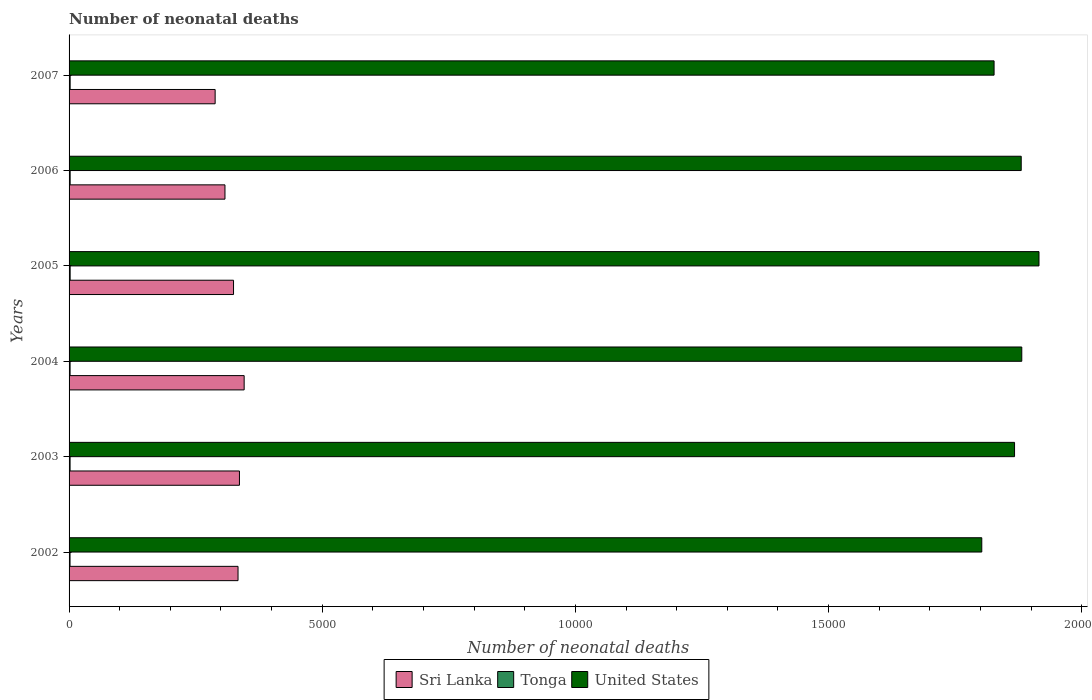How many bars are there on the 4th tick from the bottom?
Provide a succinct answer. 3. In how many cases, is the number of bars for a given year not equal to the number of legend labels?
Your response must be concise. 0. What is the number of neonatal deaths in in Sri Lanka in 2004?
Your answer should be very brief. 3458. Across all years, what is the maximum number of neonatal deaths in in United States?
Give a very brief answer. 1.92e+04. Across all years, what is the minimum number of neonatal deaths in in Tonga?
Provide a short and direct response. 19. In which year was the number of neonatal deaths in in United States maximum?
Your answer should be compact. 2005. What is the total number of neonatal deaths in in Tonga in the graph?
Provide a short and direct response. 122. What is the difference between the number of neonatal deaths in in Tonga in 2002 and that in 2005?
Provide a succinct answer. -2. What is the difference between the number of neonatal deaths in in United States in 2003 and the number of neonatal deaths in in Sri Lanka in 2002?
Provide a succinct answer. 1.53e+04. What is the average number of neonatal deaths in in United States per year?
Provide a succinct answer. 1.86e+04. In the year 2004, what is the difference between the number of neonatal deaths in in United States and number of neonatal deaths in in Tonga?
Offer a very short reply. 1.88e+04. In how many years, is the number of neonatal deaths in in Tonga greater than 1000 ?
Your response must be concise. 0. What is the ratio of the number of neonatal deaths in in United States in 2004 to that in 2007?
Ensure brevity in your answer.  1.03. Is the number of neonatal deaths in in United States in 2004 less than that in 2006?
Offer a very short reply. No. Is the difference between the number of neonatal deaths in in United States in 2002 and 2003 greater than the difference between the number of neonatal deaths in in Tonga in 2002 and 2003?
Offer a terse response. No. What is the difference between the highest and the second highest number of neonatal deaths in in Tonga?
Provide a succinct answer. 0. What is the difference between the highest and the lowest number of neonatal deaths in in Tonga?
Provide a succinct answer. 2. In how many years, is the number of neonatal deaths in in Sri Lanka greater than the average number of neonatal deaths in in Sri Lanka taken over all years?
Offer a terse response. 4. Is the sum of the number of neonatal deaths in in Tonga in 2005 and 2006 greater than the maximum number of neonatal deaths in in Sri Lanka across all years?
Your answer should be compact. No. What does the 2nd bar from the top in 2005 represents?
Ensure brevity in your answer.  Tonga. What does the 1st bar from the bottom in 2005 represents?
Offer a very short reply. Sri Lanka. How many years are there in the graph?
Your response must be concise. 6. How are the legend labels stacked?
Give a very brief answer. Horizontal. What is the title of the graph?
Offer a terse response. Number of neonatal deaths. What is the label or title of the X-axis?
Offer a very short reply. Number of neonatal deaths. What is the label or title of the Y-axis?
Make the answer very short. Years. What is the Number of neonatal deaths in Sri Lanka in 2002?
Offer a terse response. 3337. What is the Number of neonatal deaths in United States in 2002?
Give a very brief answer. 1.80e+04. What is the Number of neonatal deaths of Sri Lanka in 2003?
Ensure brevity in your answer.  3365. What is the Number of neonatal deaths of United States in 2003?
Make the answer very short. 1.87e+04. What is the Number of neonatal deaths of Sri Lanka in 2004?
Ensure brevity in your answer.  3458. What is the Number of neonatal deaths in Tonga in 2004?
Provide a short and direct response. 20. What is the Number of neonatal deaths in United States in 2004?
Ensure brevity in your answer.  1.88e+04. What is the Number of neonatal deaths of Sri Lanka in 2005?
Your response must be concise. 3248. What is the Number of neonatal deaths of United States in 2005?
Keep it short and to the point. 1.92e+04. What is the Number of neonatal deaths of Sri Lanka in 2006?
Make the answer very short. 3079. What is the Number of neonatal deaths in United States in 2006?
Keep it short and to the point. 1.88e+04. What is the Number of neonatal deaths of Sri Lanka in 2007?
Make the answer very short. 2885. What is the Number of neonatal deaths in United States in 2007?
Offer a terse response. 1.83e+04. Across all years, what is the maximum Number of neonatal deaths of Sri Lanka?
Offer a very short reply. 3458. Across all years, what is the maximum Number of neonatal deaths of United States?
Keep it short and to the point. 1.92e+04. Across all years, what is the minimum Number of neonatal deaths in Sri Lanka?
Provide a succinct answer. 2885. Across all years, what is the minimum Number of neonatal deaths of United States?
Provide a short and direct response. 1.80e+04. What is the total Number of neonatal deaths of Sri Lanka in the graph?
Provide a short and direct response. 1.94e+04. What is the total Number of neonatal deaths in Tonga in the graph?
Provide a succinct answer. 122. What is the total Number of neonatal deaths in United States in the graph?
Your answer should be compact. 1.12e+05. What is the difference between the Number of neonatal deaths of Sri Lanka in 2002 and that in 2003?
Ensure brevity in your answer.  -28. What is the difference between the Number of neonatal deaths of United States in 2002 and that in 2003?
Make the answer very short. -647. What is the difference between the Number of neonatal deaths in Sri Lanka in 2002 and that in 2004?
Ensure brevity in your answer.  -121. What is the difference between the Number of neonatal deaths in Tonga in 2002 and that in 2004?
Your answer should be compact. -1. What is the difference between the Number of neonatal deaths of United States in 2002 and that in 2004?
Offer a terse response. -790. What is the difference between the Number of neonatal deaths of Sri Lanka in 2002 and that in 2005?
Keep it short and to the point. 89. What is the difference between the Number of neonatal deaths of United States in 2002 and that in 2005?
Provide a succinct answer. -1130. What is the difference between the Number of neonatal deaths in Sri Lanka in 2002 and that in 2006?
Provide a short and direct response. 258. What is the difference between the Number of neonatal deaths of United States in 2002 and that in 2006?
Make the answer very short. -779. What is the difference between the Number of neonatal deaths in Sri Lanka in 2002 and that in 2007?
Provide a succinct answer. 452. What is the difference between the Number of neonatal deaths of Tonga in 2002 and that in 2007?
Offer a very short reply. -2. What is the difference between the Number of neonatal deaths of United States in 2002 and that in 2007?
Make the answer very short. -243. What is the difference between the Number of neonatal deaths of Sri Lanka in 2003 and that in 2004?
Keep it short and to the point. -93. What is the difference between the Number of neonatal deaths of Tonga in 2003 and that in 2004?
Make the answer very short. 0. What is the difference between the Number of neonatal deaths of United States in 2003 and that in 2004?
Keep it short and to the point. -143. What is the difference between the Number of neonatal deaths in Sri Lanka in 2003 and that in 2005?
Offer a very short reply. 117. What is the difference between the Number of neonatal deaths in United States in 2003 and that in 2005?
Provide a succinct answer. -483. What is the difference between the Number of neonatal deaths of Sri Lanka in 2003 and that in 2006?
Provide a short and direct response. 286. What is the difference between the Number of neonatal deaths in United States in 2003 and that in 2006?
Provide a short and direct response. -132. What is the difference between the Number of neonatal deaths in Sri Lanka in 2003 and that in 2007?
Make the answer very short. 480. What is the difference between the Number of neonatal deaths of Tonga in 2003 and that in 2007?
Offer a terse response. -1. What is the difference between the Number of neonatal deaths in United States in 2003 and that in 2007?
Provide a succinct answer. 404. What is the difference between the Number of neonatal deaths in Sri Lanka in 2004 and that in 2005?
Offer a very short reply. 210. What is the difference between the Number of neonatal deaths of United States in 2004 and that in 2005?
Provide a short and direct response. -340. What is the difference between the Number of neonatal deaths in Sri Lanka in 2004 and that in 2006?
Ensure brevity in your answer.  379. What is the difference between the Number of neonatal deaths in Tonga in 2004 and that in 2006?
Your answer should be compact. -1. What is the difference between the Number of neonatal deaths in United States in 2004 and that in 2006?
Make the answer very short. 11. What is the difference between the Number of neonatal deaths of Sri Lanka in 2004 and that in 2007?
Offer a terse response. 573. What is the difference between the Number of neonatal deaths of Tonga in 2004 and that in 2007?
Give a very brief answer. -1. What is the difference between the Number of neonatal deaths in United States in 2004 and that in 2007?
Provide a succinct answer. 547. What is the difference between the Number of neonatal deaths in Sri Lanka in 2005 and that in 2006?
Offer a terse response. 169. What is the difference between the Number of neonatal deaths in United States in 2005 and that in 2006?
Give a very brief answer. 351. What is the difference between the Number of neonatal deaths of Sri Lanka in 2005 and that in 2007?
Ensure brevity in your answer.  363. What is the difference between the Number of neonatal deaths in United States in 2005 and that in 2007?
Ensure brevity in your answer.  887. What is the difference between the Number of neonatal deaths of Sri Lanka in 2006 and that in 2007?
Offer a terse response. 194. What is the difference between the Number of neonatal deaths of United States in 2006 and that in 2007?
Your answer should be compact. 536. What is the difference between the Number of neonatal deaths of Sri Lanka in 2002 and the Number of neonatal deaths of Tonga in 2003?
Your answer should be very brief. 3317. What is the difference between the Number of neonatal deaths in Sri Lanka in 2002 and the Number of neonatal deaths in United States in 2003?
Ensure brevity in your answer.  -1.53e+04. What is the difference between the Number of neonatal deaths in Tonga in 2002 and the Number of neonatal deaths in United States in 2003?
Your response must be concise. -1.87e+04. What is the difference between the Number of neonatal deaths in Sri Lanka in 2002 and the Number of neonatal deaths in Tonga in 2004?
Your answer should be very brief. 3317. What is the difference between the Number of neonatal deaths in Sri Lanka in 2002 and the Number of neonatal deaths in United States in 2004?
Offer a very short reply. -1.55e+04. What is the difference between the Number of neonatal deaths of Tonga in 2002 and the Number of neonatal deaths of United States in 2004?
Your answer should be compact. -1.88e+04. What is the difference between the Number of neonatal deaths in Sri Lanka in 2002 and the Number of neonatal deaths in Tonga in 2005?
Your answer should be very brief. 3316. What is the difference between the Number of neonatal deaths in Sri Lanka in 2002 and the Number of neonatal deaths in United States in 2005?
Provide a short and direct response. -1.58e+04. What is the difference between the Number of neonatal deaths of Tonga in 2002 and the Number of neonatal deaths of United States in 2005?
Provide a short and direct response. -1.91e+04. What is the difference between the Number of neonatal deaths in Sri Lanka in 2002 and the Number of neonatal deaths in Tonga in 2006?
Provide a short and direct response. 3316. What is the difference between the Number of neonatal deaths of Sri Lanka in 2002 and the Number of neonatal deaths of United States in 2006?
Ensure brevity in your answer.  -1.55e+04. What is the difference between the Number of neonatal deaths of Tonga in 2002 and the Number of neonatal deaths of United States in 2006?
Provide a succinct answer. -1.88e+04. What is the difference between the Number of neonatal deaths of Sri Lanka in 2002 and the Number of neonatal deaths of Tonga in 2007?
Ensure brevity in your answer.  3316. What is the difference between the Number of neonatal deaths of Sri Lanka in 2002 and the Number of neonatal deaths of United States in 2007?
Make the answer very short. -1.49e+04. What is the difference between the Number of neonatal deaths of Tonga in 2002 and the Number of neonatal deaths of United States in 2007?
Your answer should be compact. -1.82e+04. What is the difference between the Number of neonatal deaths of Sri Lanka in 2003 and the Number of neonatal deaths of Tonga in 2004?
Your response must be concise. 3345. What is the difference between the Number of neonatal deaths of Sri Lanka in 2003 and the Number of neonatal deaths of United States in 2004?
Provide a succinct answer. -1.55e+04. What is the difference between the Number of neonatal deaths of Tonga in 2003 and the Number of neonatal deaths of United States in 2004?
Provide a short and direct response. -1.88e+04. What is the difference between the Number of neonatal deaths of Sri Lanka in 2003 and the Number of neonatal deaths of Tonga in 2005?
Offer a very short reply. 3344. What is the difference between the Number of neonatal deaths of Sri Lanka in 2003 and the Number of neonatal deaths of United States in 2005?
Offer a terse response. -1.58e+04. What is the difference between the Number of neonatal deaths in Tonga in 2003 and the Number of neonatal deaths in United States in 2005?
Your answer should be compact. -1.91e+04. What is the difference between the Number of neonatal deaths in Sri Lanka in 2003 and the Number of neonatal deaths in Tonga in 2006?
Offer a very short reply. 3344. What is the difference between the Number of neonatal deaths in Sri Lanka in 2003 and the Number of neonatal deaths in United States in 2006?
Make the answer very short. -1.54e+04. What is the difference between the Number of neonatal deaths of Tonga in 2003 and the Number of neonatal deaths of United States in 2006?
Make the answer very short. -1.88e+04. What is the difference between the Number of neonatal deaths of Sri Lanka in 2003 and the Number of neonatal deaths of Tonga in 2007?
Your answer should be very brief. 3344. What is the difference between the Number of neonatal deaths of Sri Lanka in 2003 and the Number of neonatal deaths of United States in 2007?
Your answer should be very brief. -1.49e+04. What is the difference between the Number of neonatal deaths of Tonga in 2003 and the Number of neonatal deaths of United States in 2007?
Give a very brief answer. -1.82e+04. What is the difference between the Number of neonatal deaths in Sri Lanka in 2004 and the Number of neonatal deaths in Tonga in 2005?
Ensure brevity in your answer.  3437. What is the difference between the Number of neonatal deaths in Sri Lanka in 2004 and the Number of neonatal deaths in United States in 2005?
Offer a terse response. -1.57e+04. What is the difference between the Number of neonatal deaths of Tonga in 2004 and the Number of neonatal deaths of United States in 2005?
Your response must be concise. -1.91e+04. What is the difference between the Number of neonatal deaths of Sri Lanka in 2004 and the Number of neonatal deaths of Tonga in 2006?
Offer a terse response. 3437. What is the difference between the Number of neonatal deaths of Sri Lanka in 2004 and the Number of neonatal deaths of United States in 2006?
Provide a short and direct response. -1.53e+04. What is the difference between the Number of neonatal deaths of Tonga in 2004 and the Number of neonatal deaths of United States in 2006?
Offer a terse response. -1.88e+04. What is the difference between the Number of neonatal deaths of Sri Lanka in 2004 and the Number of neonatal deaths of Tonga in 2007?
Your answer should be very brief. 3437. What is the difference between the Number of neonatal deaths in Sri Lanka in 2004 and the Number of neonatal deaths in United States in 2007?
Your response must be concise. -1.48e+04. What is the difference between the Number of neonatal deaths in Tonga in 2004 and the Number of neonatal deaths in United States in 2007?
Offer a very short reply. -1.82e+04. What is the difference between the Number of neonatal deaths in Sri Lanka in 2005 and the Number of neonatal deaths in Tonga in 2006?
Give a very brief answer. 3227. What is the difference between the Number of neonatal deaths in Sri Lanka in 2005 and the Number of neonatal deaths in United States in 2006?
Offer a very short reply. -1.56e+04. What is the difference between the Number of neonatal deaths of Tonga in 2005 and the Number of neonatal deaths of United States in 2006?
Keep it short and to the point. -1.88e+04. What is the difference between the Number of neonatal deaths of Sri Lanka in 2005 and the Number of neonatal deaths of Tonga in 2007?
Provide a short and direct response. 3227. What is the difference between the Number of neonatal deaths of Sri Lanka in 2005 and the Number of neonatal deaths of United States in 2007?
Ensure brevity in your answer.  -1.50e+04. What is the difference between the Number of neonatal deaths of Tonga in 2005 and the Number of neonatal deaths of United States in 2007?
Offer a terse response. -1.82e+04. What is the difference between the Number of neonatal deaths of Sri Lanka in 2006 and the Number of neonatal deaths of Tonga in 2007?
Your response must be concise. 3058. What is the difference between the Number of neonatal deaths of Sri Lanka in 2006 and the Number of neonatal deaths of United States in 2007?
Offer a very short reply. -1.52e+04. What is the difference between the Number of neonatal deaths of Tonga in 2006 and the Number of neonatal deaths of United States in 2007?
Provide a succinct answer. -1.82e+04. What is the average Number of neonatal deaths in Sri Lanka per year?
Offer a very short reply. 3228.67. What is the average Number of neonatal deaths in Tonga per year?
Provide a short and direct response. 20.33. What is the average Number of neonatal deaths in United States per year?
Keep it short and to the point. 1.86e+04. In the year 2002, what is the difference between the Number of neonatal deaths of Sri Lanka and Number of neonatal deaths of Tonga?
Keep it short and to the point. 3318. In the year 2002, what is the difference between the Number of neonatal deaths of Sri Lanka and Number of neonatal deaths of United States?
Provide a short and direct response. -1.47e+04. In the year 2002, what is the difference between the Number of neonatal deaths in Tonga and Number of neonatal deaths in United States?
Your answer should be compact. -1.80e+04. In the year 2003, what is the difference between the Number of neonatal deaths of Sri Lanka and Number of neonatal deaths of Tonga?
Ensure brevity in your answer.  3345. In the year 2003, what is the difference between the Number of neonatal deaths in Sri Lanka and Number of neonatal deaths in United States?
Keep it short and to the point. -1.53e+04. In the year 2003, what is the difference between the Number of neonatal deaths of Tonga and Number of neonatal deaths of United States?
Offer a very short reply. -1.87e+04. In the year 2004, what is the difference between the Number of neonatal deaths in Sri Lanka and Number of neonatal deaths in Tonga?
Make the answer very short. 3438. In the year 2004, what is the difference between the Number of neonatal deaths in Sri Lanka and Number of neonatal deaths in United States?
Keep it short and to the point. -1.54e+04. In the year 2004, what is the difference between the Number of neonatal deaths in Tonga and Number of neonatal deaths in United States?
Your answer should be compact. -1.88e+04. In the year 2005, what is the difference between the Number of neonatal deaths in Sri Lanka and Number of neonatal deaths in Tonga?
Offer a terse response. 3227. In the year 2005, what is the difference between the Number of neonatal deaths in Sri Lanka and Number of neonatal deaths in United States?
Ensure brevity in your answer.  -1.59e+04. In the year 2005, what is the difference between the Number of neonatal deaths of Tonga and Number of neonatal deaths of United States?
Your answer should be very brief. -1.91e+04. In the year 2006, what is the difference between the Number of neonatal deaths of Sri Lanka and Number of neonatal deaths of Tonga?
Provide a succinct answer. 3058. In the year 2006, what is the difference between the Number of neonatal deaths in Sri Lanka and Number of neonatal deaths in United States?
Provide a short and direct response. -1.57e+04. In the year 2006, what is the difference between the Number of neonatal deaths of Tonga and Number of neonatal deaths of United States?
Keep it short and to the point. -1.88e+04. In the year 2007, what is the difference between the Number of neonatal deaths in Sri Lanka and Number of neonatal deaths in Tonga?
Give a very brief answer. 2864. In the year 2007, what is the difference between the Number of neonatal deaths in Sri Lanka and Number of neonatal deaths in United States?
Offer a very short reply. -1.54e+04. In the year 2007, what is the difference between the Number of neonatal deaths in Tonga and Number of neonatal deaths in United States?
Offer a very short reply. -1.82e+04. What is the ratio of the Number of neonatal deaths of United States in 2002 to that in 2003?
Offer a terse response. 0.97. What is the ratio of the Number of neonatal deaths in United States in 2002 to that in 2004?
Your answer should be very brief. 0.96. What is the ratio of the Number of neonatal deaths of Sri Lanka in 2002 to that in 2005?
Your answer should be very brief. 1.03. What is the ratio of the Number of neonatal deaths in Tonga in 2002 to that in 2005?
Offer a very short reply. 0.9. What is the ratio of the Number of neonatal deaths of United States in 2002 to that in 2005?
Ensure brevity in your answer.  0.94. What is the ratio of the Number of neonatal deaths of Sri Lanka in 2002 to that in 2006?
Ensure brevity in your answer.  1.08. What is the ratio of the Number of neonatal deaths of Tonga in 2002 to that in 2006?
Your answer should be very brief. 0.9. What is the ratio of the Number of neonatal deaths in United States in 2002 to that in 2006?
Keep it short and to the point. 0.96. What is the ratio of the Number of neonatal deaths of Sri Lanka in 2002 to that in 2007?
Give a very brief answer. 1.16. What is the ratio of the Number of neonatal deaths in Tonga in 2002 to that in 2007?
Offer a terse response. 0.9. What is the ratio of the Number of neonatal deaths in United States in 2002 to that in 2007?
Provide a short and direct response. 0.99. What is the ratio of the Number of neonatal deaths in Sri Lanka in 2003 to that in 2004?
Give a very brief answer. 0.97. What is the ratio of the Number of neonatal deaths in Sri Lanka in 2003 to that in 2005?
Make the answer very short. 1.04. What is the ratio of the Number of neonatal deaths of United States in 2003 to that in 2005?
Your answer should be very brief. 0.97. What is the ratio of the Number of neonatal deaths of Sri Lanka in 2003 to that in 2006?
Keep it short and to the point. 1.09. What is the ratio of the Number of neonatal deaths of United States in 2003 to that in 2006?
Provide a short and direct response. 0.99. What is the ratio of the Number of neonatal deaths of Sri Lanka in 2003 to that in 2007?
Your answer should be compact. 1.17. What is the ratio of the Number of neonatal deaths of Tonga in 2003 to that in 2007?
Provide a short and direct response. 0.95. What is the ratio of the Number of neonatal deaths of United States in 2003 to that in 2007?
Your response must be concise. 1.02. What is the ratio of the Number of neonatal deaths in Sri Lanka in 2004 to that in 2005?
Your answer should be very brief. 1.06. What is the ratio of the Number of neonatal deaths in United States in 2004 to that in 2005?
Give a very brief answer. 0.98. What is the ratio of the Number of neonatal deaths of Sri Lanka in 2004 to that in 2006?
Your answer should be very brief. 1.12. What is the ratio of the Number of neonatal deaths in Sri Lanka in 2004 to that in 2007?
Provide a short and direct response. 1.2. What is the ratio of the Number of neonatal deaths of United States in 2004 to that in 2007?
Offer a terse response. 1.03. What is the ratio of the Number of neonatal deaths of Sri Lanka in 2005 to that in 2006?
Provide a short and direct response. 1.05. What is the ratio of the Number of neonatal deaths of Tonga in 2005 to that in 2006?
Your response must be concise. 1. What is the ratio of the Number of neonatal deaths of United States in 2005 to that in 2006?
Provide a succinct answer. 1.02. What is the ratio of the Number of neonatal deaths in Sri Lanka in 2005 to that in 2007?
Provide a succinct answer. 1.13. What is the ratio of the Number of neonatal deaths in United States in 2005 to that in 2007?
Your response must be concise. 1.05. What is the ratio of the Number of neonatal deaths in Sri Lanka in 2006 to that in 2007?
Ensure brevity in your answer.  1.07. What is the ratio of the Number of neonatal deaths of Tonga in 2006 to that in 2007?
Make the answer very short. 1. What is the ratio of the Number of neonatal deaths in United States in 2006 to that in 2007?
Ensure brevity in your answer.  1.03. What is the difference between the highest and the second highest Number of neonatal deaths in Sri Lanka?
Offer a very short reply. 93. What is the difference between the highest and the second highest Number of neonatal deaths in United States?
Make the answer very short. 340. What is the difference between the highest and the lowest Number of neonatal deaths in Sri Lanka?
Provide a short and direct response. 573. What is the difference between the highest and the lowest Number of neonatal deaths in Tonga?
Your response must be concise. 2. What is the difference between the highest and the lowest Number of neonatal deaths of United States?
Offer a terse response. 1130. 